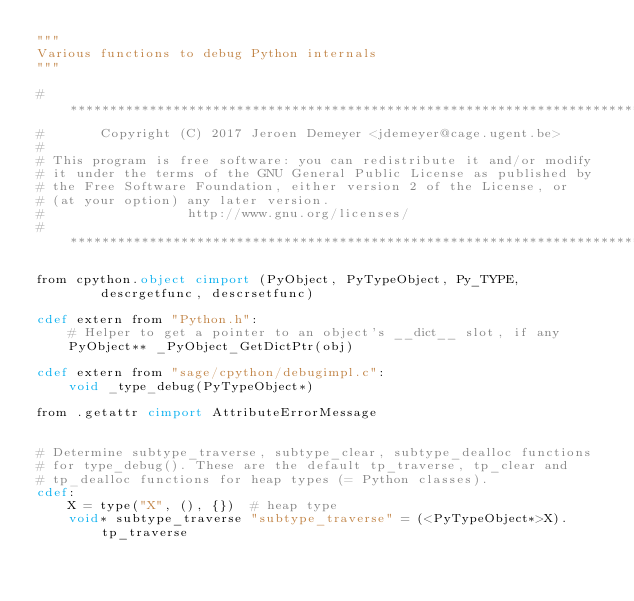<code> <loc_0><loc_0><loc_500><loc_500><_Cython_>"""
Various functions to debug Python internals
"""

#*****************************************************************************
#       Copyright (C) 2017 Jeroen Demeyer <jdemeyer@cage.ugent.be>
#
# This program is free software: you can redistribute it and/or modify
# it under the terms of the GNU General Public License as published by
# the Free Software Foundation, either version 2 of the License, or
# (at your option) any later version.
#                  http://www.gnu.org/licenses/
#*****************************************************************************

from cpython.object cimport (PyObject, PyTypeObject, Py_TYPE,
        descrgetfunc, descrsetfunc)

cdef extern from "Python.h":
    # Helper to get a pointer to an object's __dict__ slot, if any
    PyObject** _PyObject_GetDictPtr(obj)

cdef extern from "sage/cpython/debugimpl.c":
    void _type_debug(PyTypeObject*)

from .getattr cimport AttributeErrorMessage


# Determine subtype_traverse, subtype_clear, subtype_dealloc functions
# for type_debug(). These are the default tp_traverse, tp_clear and
# tp_dealloc functions for heap types (= Python classes).
cdef:
    X = type("X", (), {})  # heap type
    void* subtype_traverse "subtype_traverse" = (<PyTypeObject*>X).tp_traverse</code> 